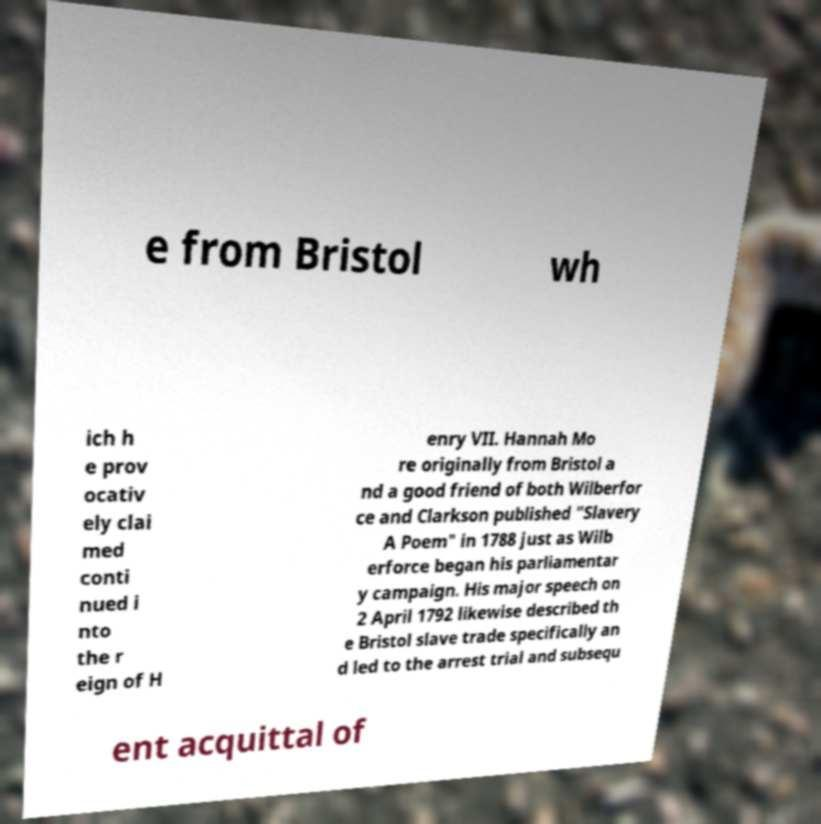Can you accurately transcribe the text from the provided image for me? e from Bristol wh ich h e prov ocativ ely clai med conti nued i nto the r eign of H enry VII. Hannah Mo re originally from Bristol a nd a good friend of both Wilberfor ce and Clarkson published "Slavery A Poem" in 1788 just as Wilb erforce began his parliamentar y campaign. His major speech on 2 April 1792 likewise described th e Bristol slave trade specifically an d led to the arrest trial and subsequ ent acquittal of 